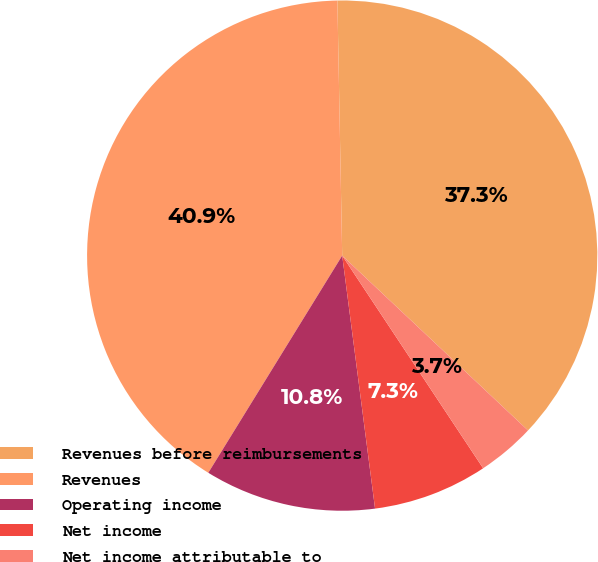Convert chart to OTSL. <chart><loc_0><loc_0><loc_500><loc_500><pie_chart><fcel>Revenues before reimbursements<fcel>Revenues<fcel>Operating income<fcel>Net income<fcel>Net income attributable to<nl><fcel>37.32%<fcel>40.91%<fcel>10.85%<fcel>7.26%<fcel>3.67%<nl></chart> 